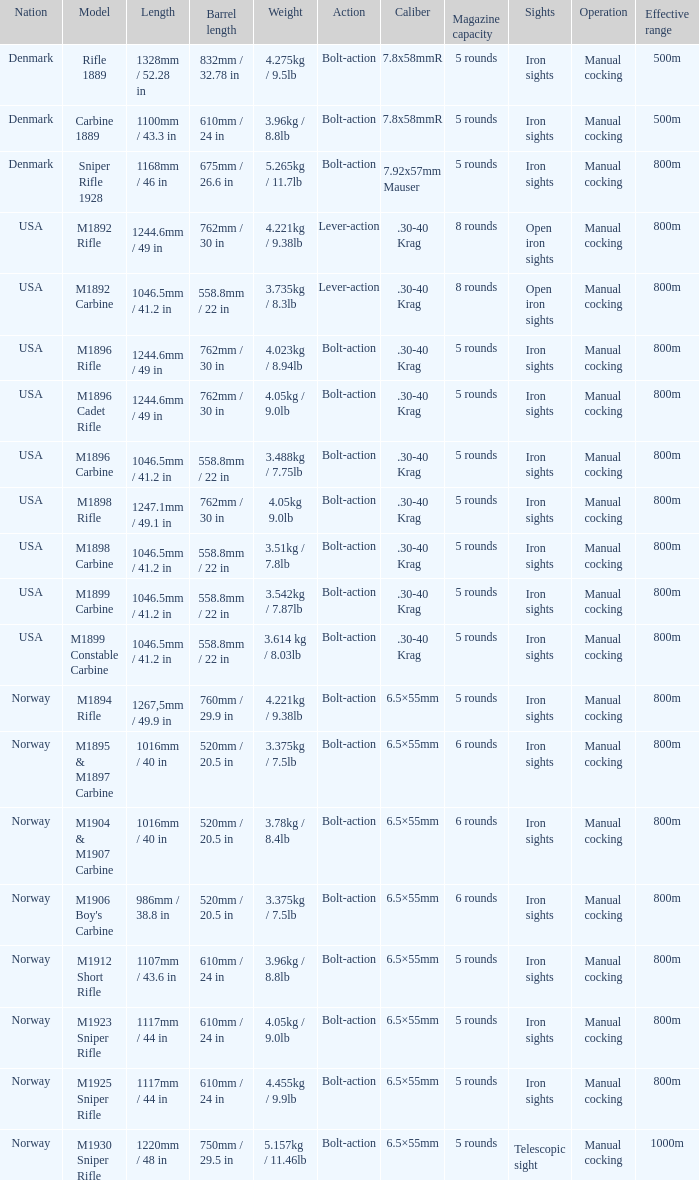What is Nation, when Model is M1895 & M1897 Carbine? Norway. 